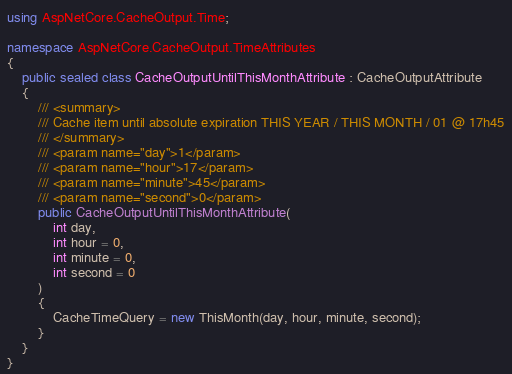<code> <loc_0><loc_0><loc_500><loc_500><_C#_>using AspNetCore.CacheOutput.Time;

namespace AspNetCore.CacheOutput.TimeAttributes
{
    public sealed class CacheOutputUntilThisMonthAttribute : CacheOutputAttribute
    {
        /// <summary>
        /// Cache item until absolute expiration THIS YEAR / THIS MONTH / 01 @ 17h45
        /// </summary>
        /// <param name="day">1</param>
        /// <param name="hour">17</param>
        /// <param name="minute">45</param>
        /// <param name="second">0</param>
        public CacheOutputUntilThisMonthAttribute(
            int day,
            int hour = 0,
            int minute = 0,
            int second = 0
        )
        {
            CacheTimeQuery = new ThisMonth(day, hour, minute, second);
        }
    }
}
</code> 